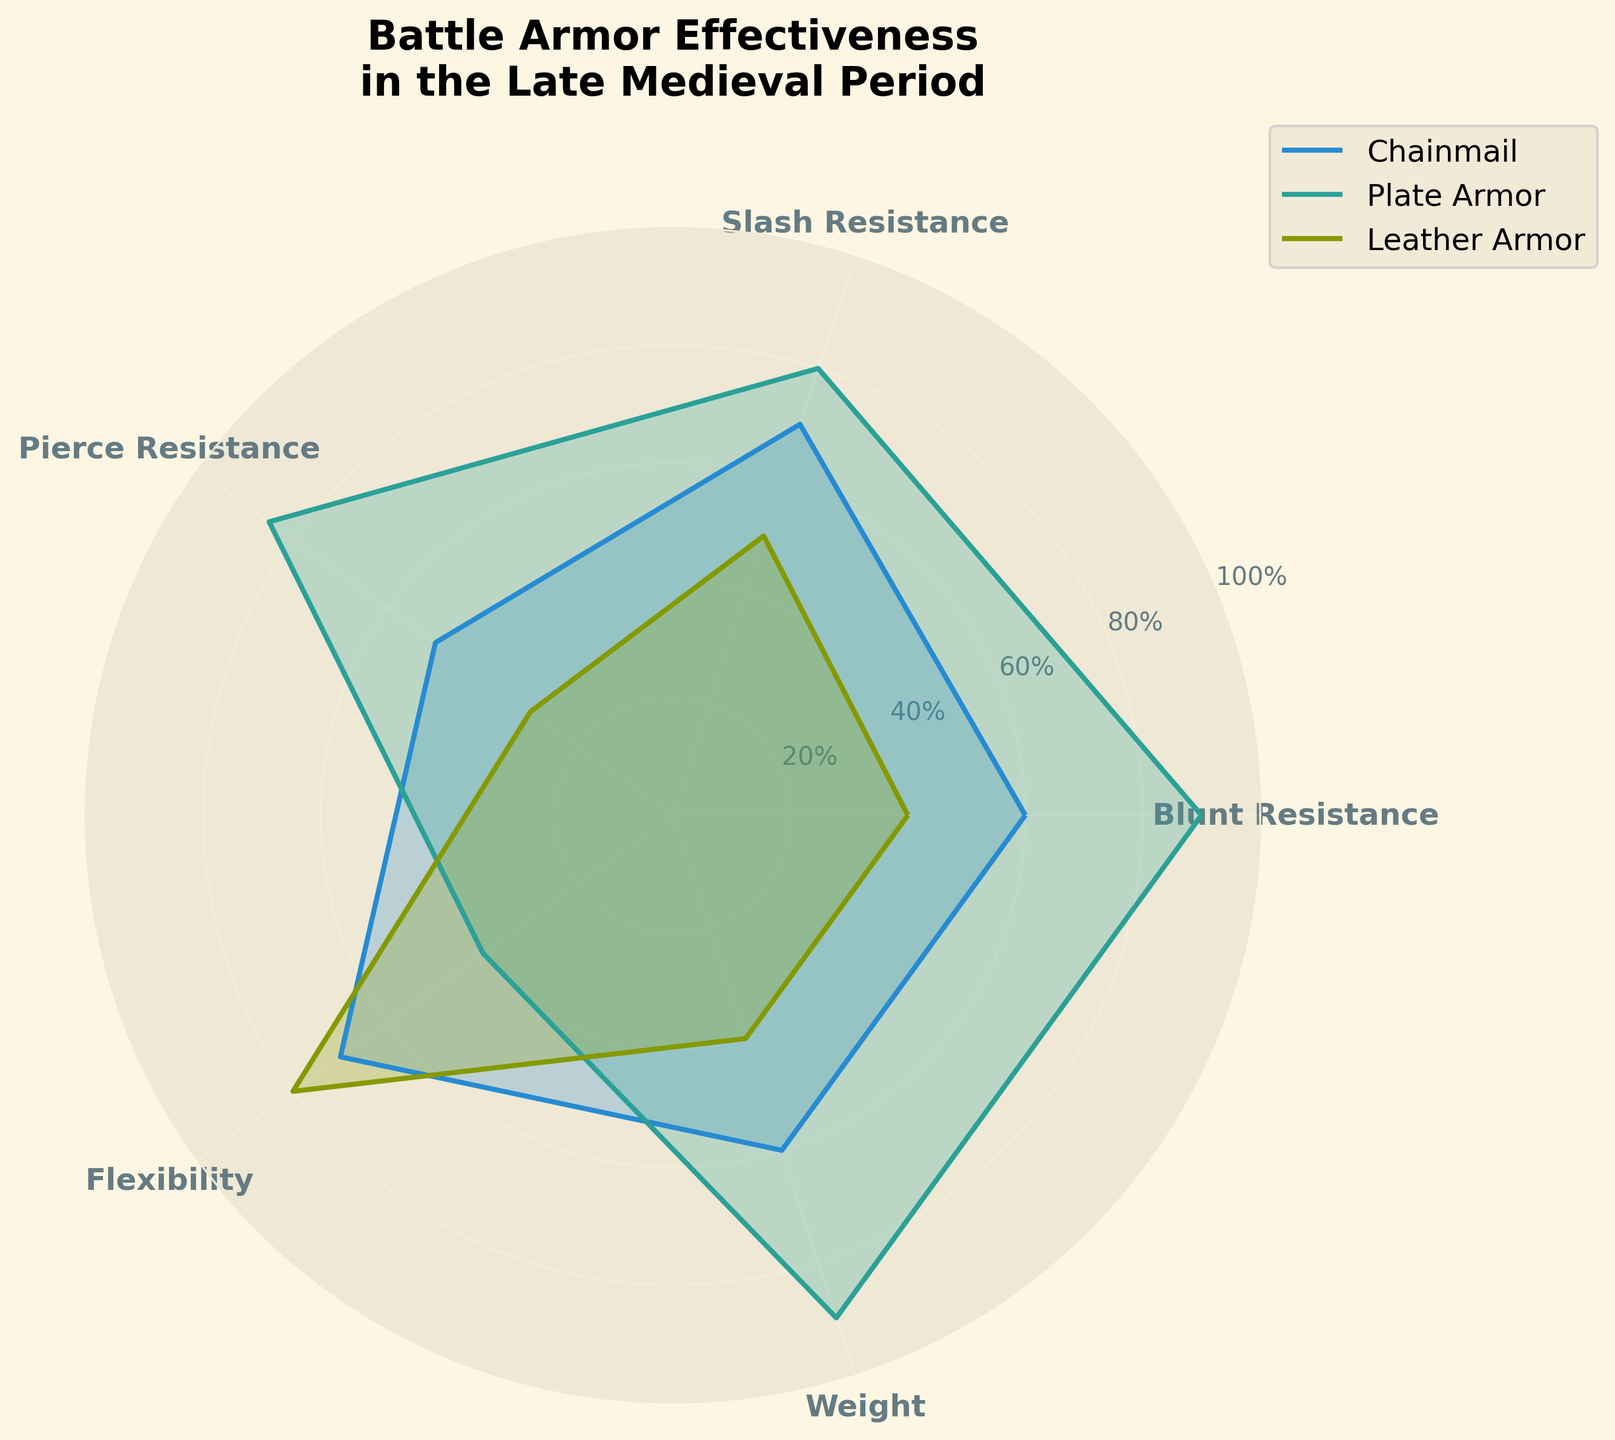What is the title of the plot? The title of the plot is usually displayed prominently at the top, indicating the main subject the figure is depicting. Here, it shows "Battle Armor Effectiveness in the Late Medieval Period."
Answer: Battle Armor Effectiveness in the Late Medieval Period How many armor types are compared in the plot? The plot compares three different armor types, as shown by the legend. These are Chainmail, Plate Armor, and Leather Armor
Answer: 3 Which armor type has the highest blunt resistance? By looking at the radar chart and comparing the blunt resistance values at the corresponding angle, we observe that Plate Armor reaches the highest value at this axis.
Answer: Plate Armor Which armor type is the most flexible? Flexibility is one of the dimensions plotted. Observing the flexibility points on the radar chart, Leather Armor extends the farthest on this axis, indicating the highest flexibility.
Answer: Leather Armor How does Plate Armor compare to Chainmail in terms of pierce resistance? To compare, we look at the pierce resistance points on the radar chart for both Plate Armor and Chainmail. Plate Armor reaches a value of 85, while Chainmail reaches 50. Plate Armor has a higher pierce resistance.
Answer: Plate Armor has higher pierce resistance What is the average resistance (blunt, slash, and pierce) for Leather Armor? First, we identify the values for Leather Armor: Blunt Resistance (40), Slash Resistance (50), and Pierce Resistance (30). We then calculate the average: (40 + 50 + 30) / 3 = 120 / 3 = 40.
Answer: 40 Which armor type has the largest difference between its highest and lowest resistance values? Calculate the difference for each armor type: Chainmail’s highest value is 70 (Slash Resistance, Flexibility) and lowest is 50 (Pierce Resistance), giving a difference of 20. Plate Armor’s highest value is 90 (Blunt Resistance) and lowest is 40 (Flexibility), giving a difference of 50. Leather Armor’s highest value is 80 (Flexibility) and lowest is 30 (Pierce Resistance), giving a difference of 50. Both Plate Armor and Leather Armor have equal largest differences.
Answer: Plate Armor and Leather Armor Which characteristic has the closest values for all armor types? For this, we compare the values across the different axes: Blunt, Slash, Pierce, Flexibility, and Weight. Observing the plot, we see that the weights for Chainmail (60), Plate Armor (90), and Leather Armor (40) show the smallest spread overall.
Answer: Weight What is the ratio of Chainmail's flexibility to Plate Armor's flexibility? Chainmail has a flexibility value of 70, while Plate Armor has a flexibility value of 40. The ratio is therefore 70 / 40 = 7 / 4 or 1.75.
Answer: 1.75 Between Chainmail and Leather Armor, which has a better balance of resistances (blunt, slash, and pierce)? Compare the mean and variability of resistances: The average resistance for Chainmail is (60 + 70 + 50)/3 = 60, and for Leather Armor (40 + 50 + 30)/3 = 40. Chainmail shows less variability (20 spread between all values) compared to Leather Armor (20 spread), while overall it has a higher average resistance making it more balanced.
Answer: Chainmail 